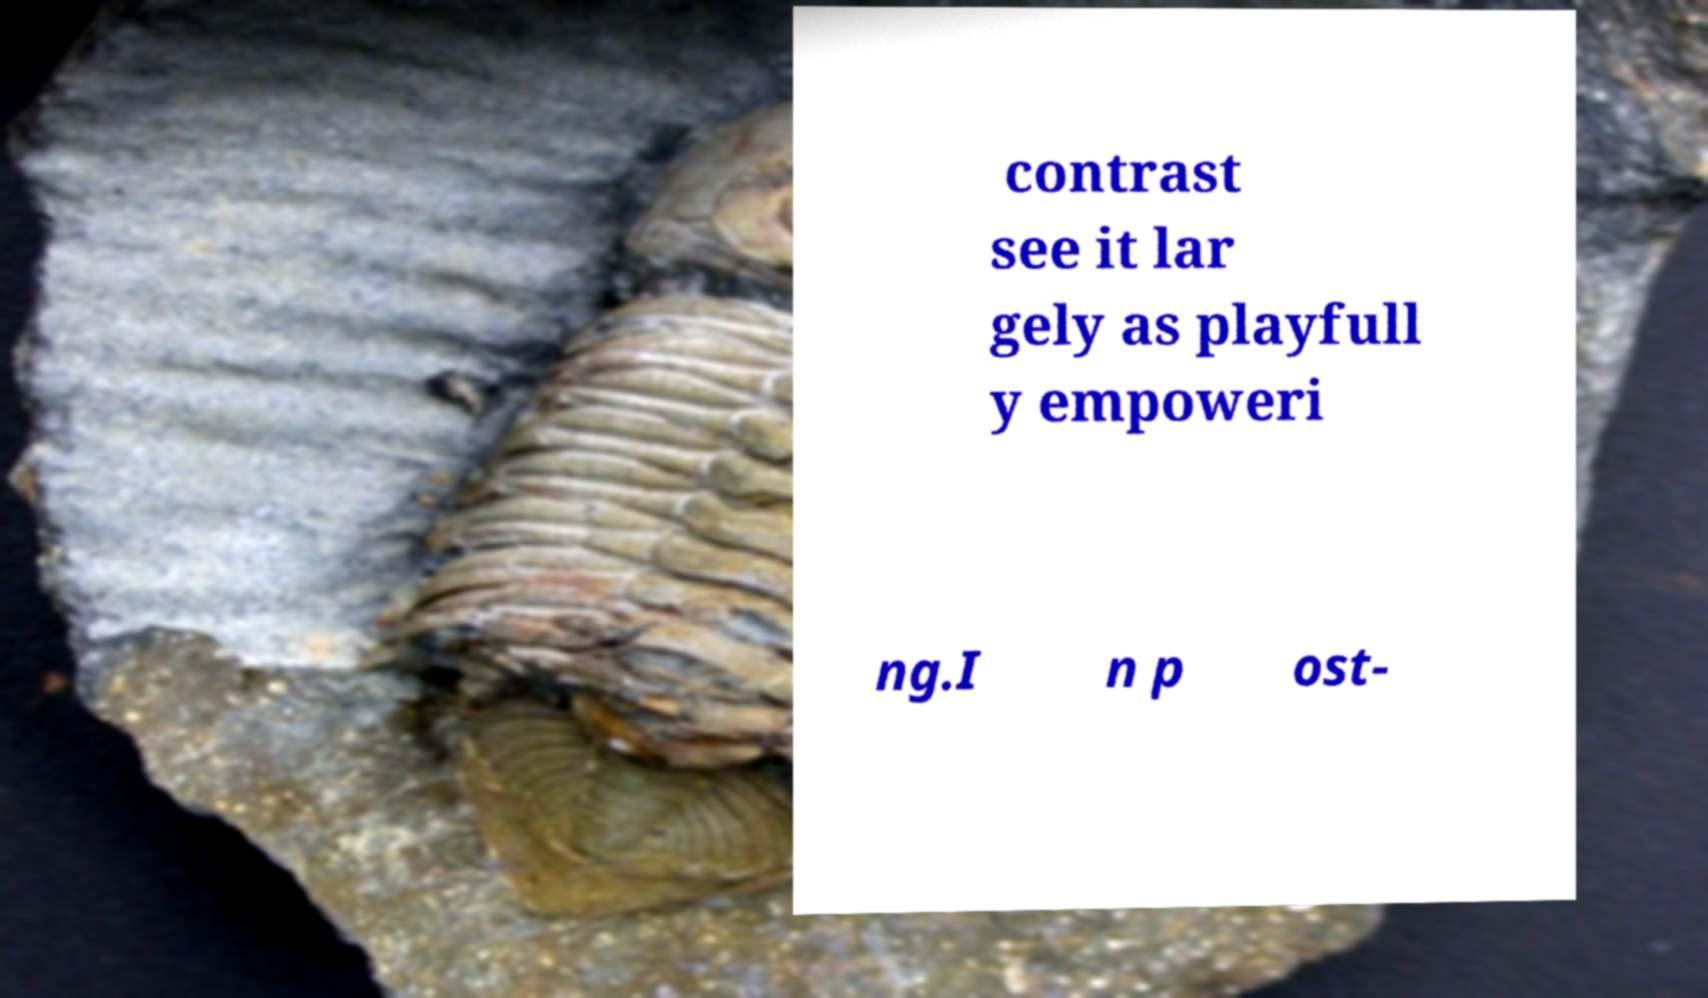Could you assist in decoding the text presented in this image and type it out clearly? contrast see it lar gely as playfull y empoweri ng.I n p ost- 